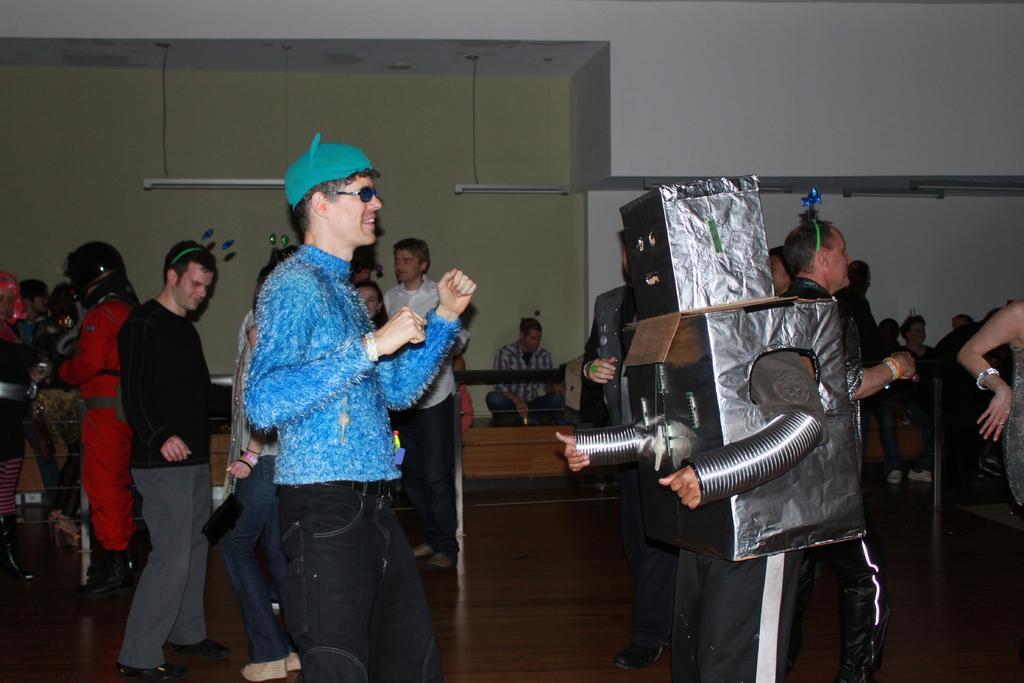In one or two sentences, can you explain what this image depicts? In this image there are so many people dancing on the floor in which one of them is wearing a robot costume and also there are lights hanging from the roof. 